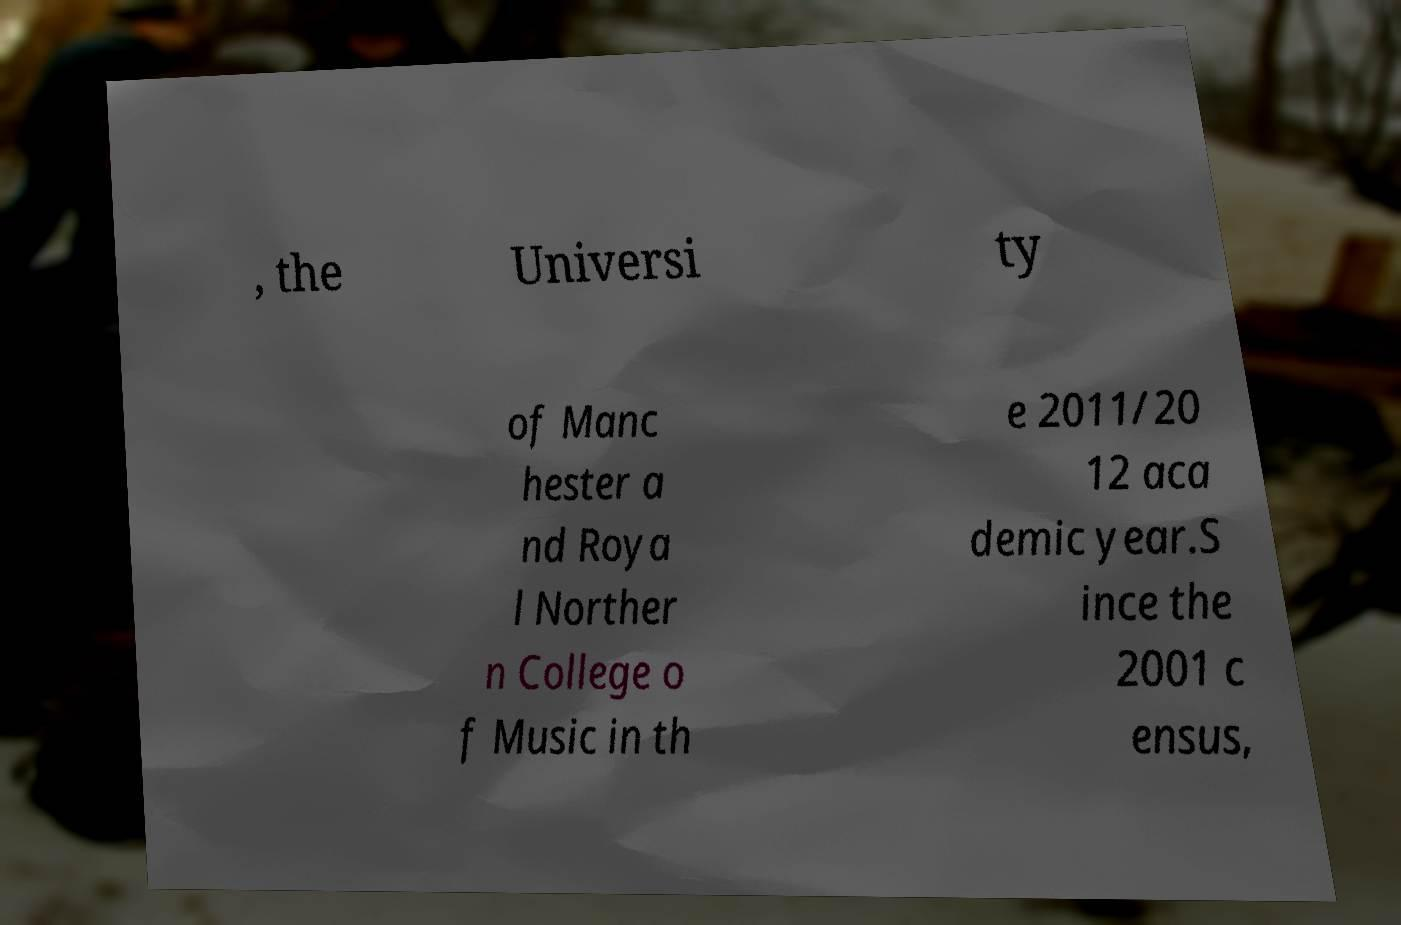Can you read and provide the text displayed in the image?This photo seems to have some interesting text. Can you extract and type it out for me? , the Universi ty of Manc hester a nd Roya l Norther n College o f Music in th e 2011/20 12 aca demic year.S ince the 2001 c ensus, 